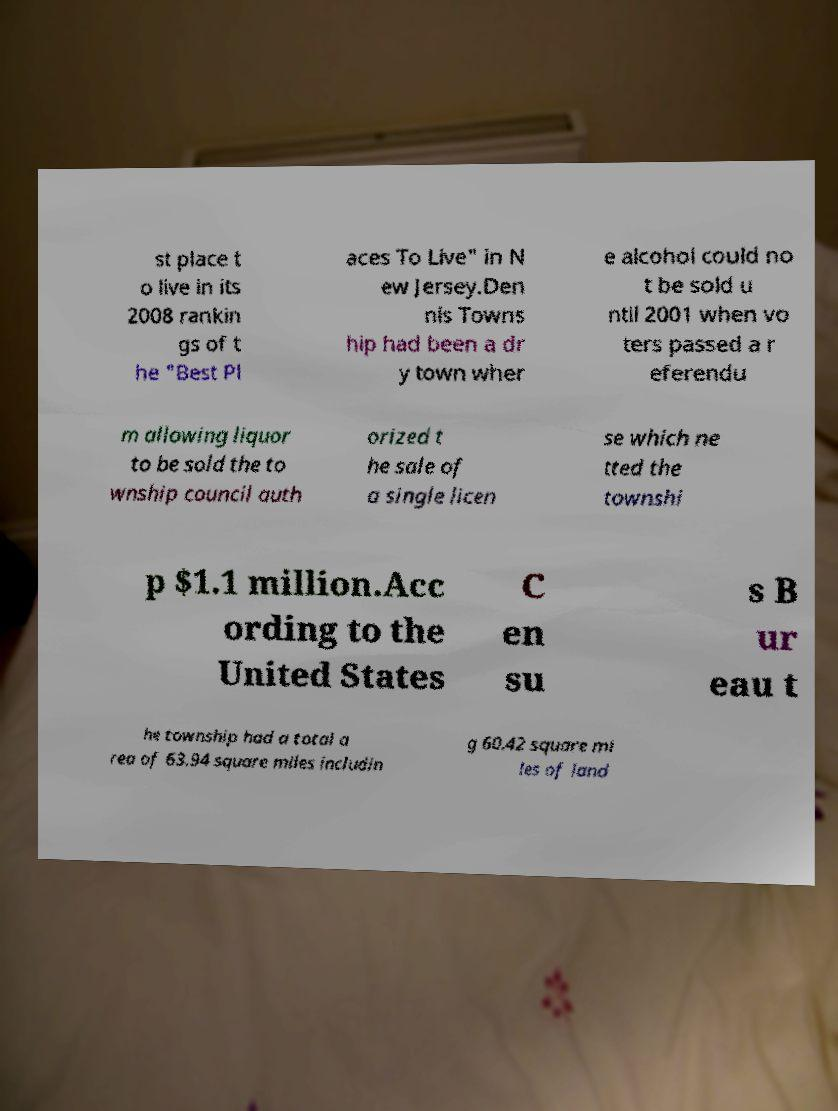What messages or text are displayed in this image? I need them in a readable, typed format. st place t o live in its 2008 rankin gs of t he "Best Pl aces To Live" in N ew Jersey.Den nis Towns hip had been a dr y town wher e alcohol could no t be sold u ntil 2001 when vo ters passed a r eferendu m allowing liquor to be sold the to wnship council auth orized t he sale of a single licen se which ne tted the townshi p $1.1 million.Acc ording to the United States C en su s B ur eau t he township had a total a rea of 63.94 square miles includin g 60.42 square mi les of land 